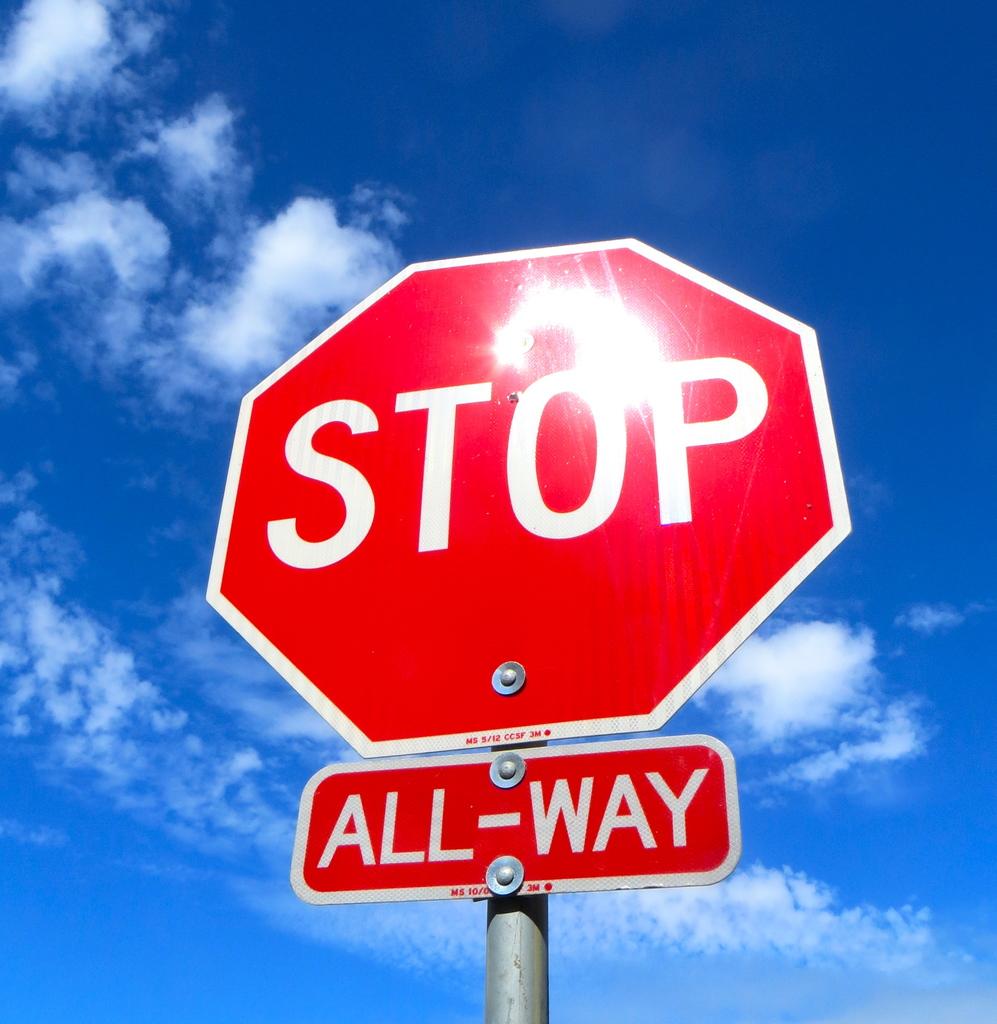What does the sign tell you to do?
Ensure brevity in your answer.  Stop. How many ways is this stop sign?
Your answer should be compact. All-way. 